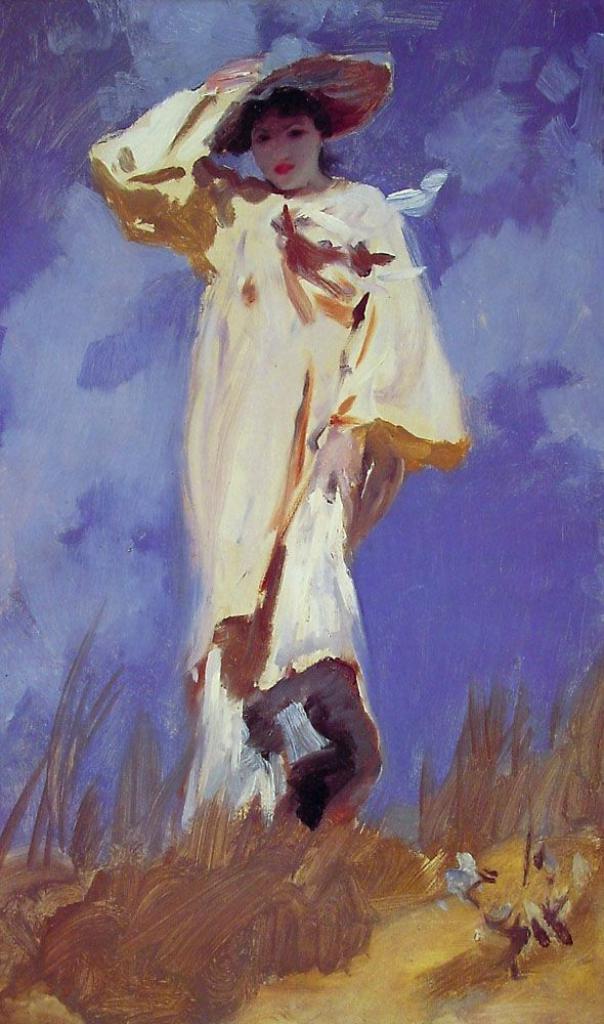Could you give a brief overview of what you see in this image? There is a painting of a woman wearing a hat. There is sky at the top. 